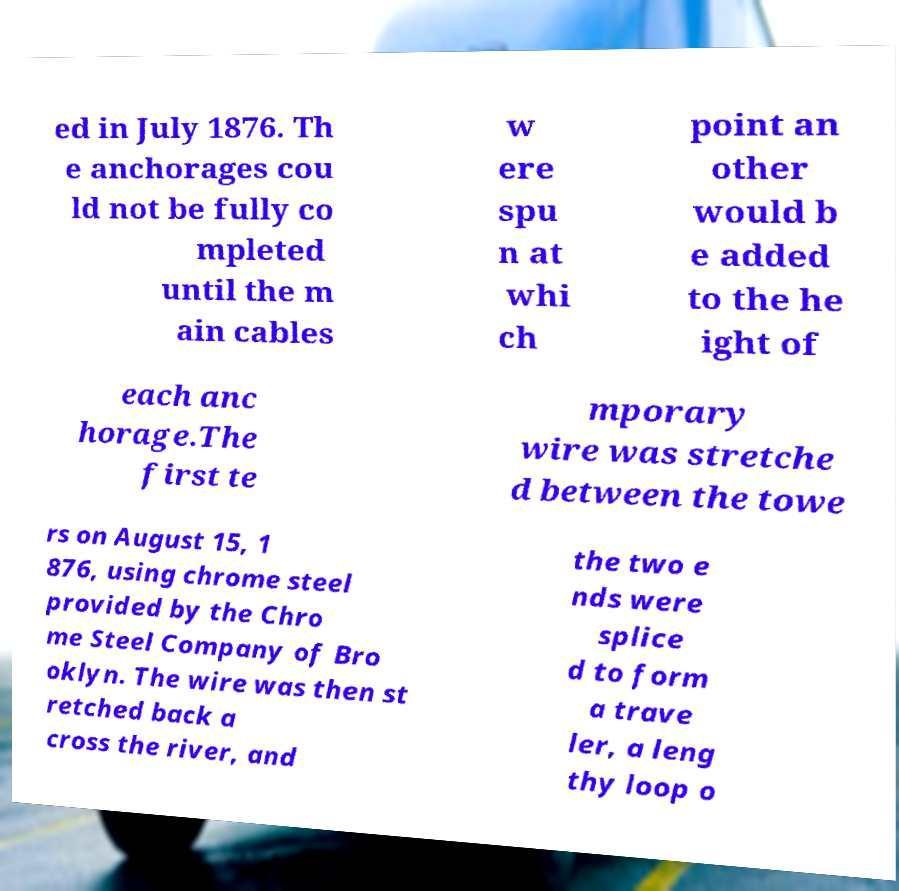Could you assist in decoding the text presented in this image and type it out clearly? ed in July 1876. Th e anchorages cou ld not be fully co mpleted until the m ain cables w ere spu n at whi ch point an other would b e added to the he ight of each anc horage.The first te mporary wire was stretche d between the towe rs on August 15, 1 876, using chrome steel provided by the Chro me Steel Company of Bro oklyn. The wire was then st retched back a cross the river, and the two e nds were splice d to form a trave ler, a leng thy loop o 